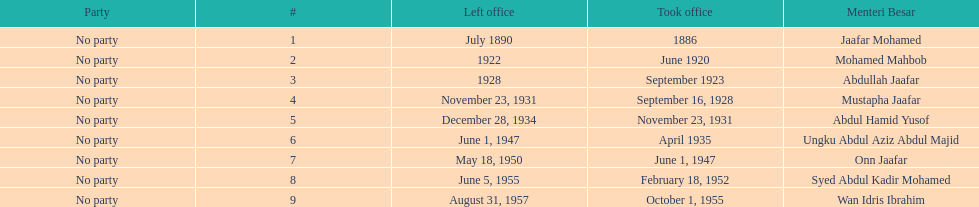How many years was jaafar mohamed in office? 4. 